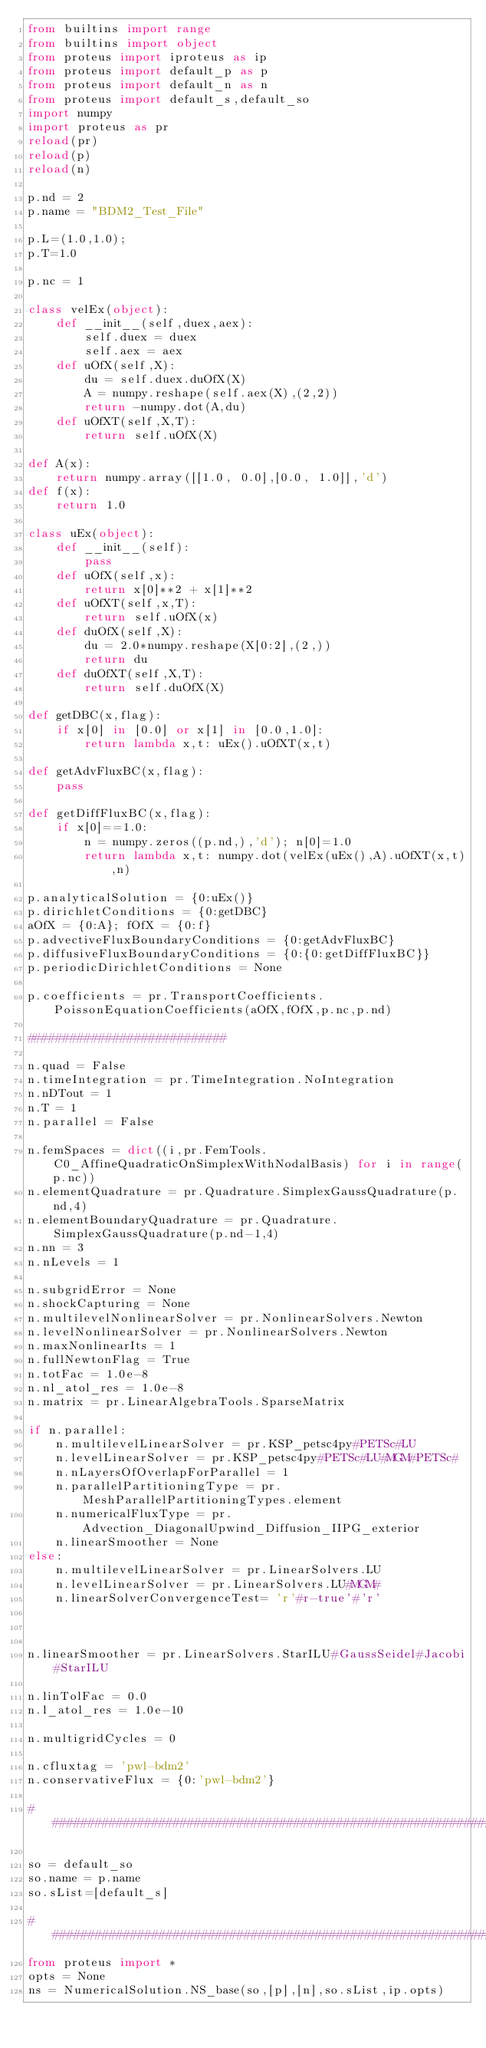<code> <loc_0><loc_0><loc_500><loc_500><_Python_>from builtins import range
from builtins import object
from proteus import iproteus as ip
from proteus import default_p as p
from proteus import default_n as n
from proteus import default_s,default_so
import numpy
import proteus as pr
reload(pr)
reload(p)
reload(n)

p.nd = 2
p.name = "BDM2_Test_File"

p.L=(1.0,1.0);
p.T=1.0

p.nc = 1

class velEx(object):
    def __init__(self,duex,aex):
        self.duex = duex
        self.aex = aex
    def uOfX(self,X):
        du = self.duex.duOfX(X)
        A = numpy.reshape(self.aex(X),(2,2))
        return -numpy.dot(A,du)
    def uOfXT(self,X,T):
        return self.uOfX(X)

def A(x):
    return numpy.array([[1.0, 0.0],[0.0, 1.0]],'d')
def f(x):
    return 1.0

class uEx(object):
    def __init__(self):
        pass
    def uOfX(self,x):
        return x[0]**2 + x[1]**2
    def uOfXT(self,x,T):
        return self.uOfX(x)
    def duOfX(self,X):
        du = 2.0*numpy.reshape(X[0:2],(2,))
        return du
    def duOfXT(self,X,T):
        return self.duOfX(X)

def getDBC(x,flag):
    if x[0] in [0.0] or x[1] in [0.0,1.0]:
        return lambda x,t: uEx().uOfXT(x,t)

def getAdvFluxBC(x,flag):
    pass

def getDiffFluxBC(x,flag):
    if x[0]==1.0:
        n = numpy.zeros((p.nd,),'d'); n[0]=1.0
        return lambda x,t: numpy.dot(velEx(uEx(),A).uOfXT(x,t),n)

p.analyticalSolution = {0:uEx()}
p.dirichletConditions = {0:getDBC}
aOfX = {0:A}; fOfX = {0:f}
p.advectiveFluxBoundaryConditions = {0:getAdvFluxBC}
p.diffusiveFluxBoundaryConditions = {0:{0:getDiffFluxBC}}
p.periodicDirichletConditions = None

p.coefficients = pr.TransportCoefficients.PoissonEquationCoefficients(aOfX,fOfX,p.nc,p.nd)

############################

n.quad = False
n.timeIntegration = pr.TimeIntegration.NoIntegration
n.nDTout = 1
n.T = 1
n.parallel = False

n.femSpaces = dict((i,pr.FemTools.C0_AffineQuadraticOnSimplexWithNodalBasis) for i in range(p.nc))
n.elementQuadrature = pr.Quadrature.SimplexGaussQuadrature(p.nd,4)
n.elementBoundaryQuadrature = pr.Quadrature.SimplexGaussQuadrature(p.nd-1,4)
n.nn = 3
n.nLevels = 1

n.subgridError = None
n.shockCapturing = None
n.multilevelNonlinearSolver = pr.NonlinearSolvers.Newton
n.levelNonlinearSolver = pr.NonlinearSolvers.Newton
n.maxNonlinearIts = 1
n.fullNewtonFlag = True
n.totFac = 1.0e-8
n.nl_atol_res = 1.0e-8
n.matrix = pr.LinearAlgebraTools.SparseMatrix

if n.parallel:
    n.multilevelLinearSolver = pr.KSP_petsc4py#PETSc#LU
    n.levelLinearSolver = pr.KSP_petsc4py#PETSc#LU#MGM#PETSc#
    n.nLayersOfOverlapForParallel = 1
    n.parallelPartitioningType = pr.MeshParallelPartitioningTypes.element
    n.numericalFluxType = pr.Advection_DiagonalUpwind_Diffusion_IIPG_exterior
    n.linearSmoother = None
else:
    n.multilevelLinearSolver = pr.LinearSolvers.LU
    n.levelLinearSolver = pr.LinearSolvers.LU#MGM#
    n.linearSolverConvergenceTest= 'r'#r-true'#'r'



n.linearSmoother = pr.LinearSolvers.StarILU#GaussSeidel#Jacobi#StarILU

n.linTolFac = 0.0
n.l_atol_res = 1.0e-10

n.multigridCycles = 0

n.cfluxtag = 'pwl-bdm2'
n.conservativeFlux = {0:'pwl-bdm2'}

#########################################################################

so = default_so
so.name = p.name 
so.sList=[default_s]

########################################################################
from proteus import *
opts = None
ns = NumericalSolution.NS_base(so,[p],[n],so.sList,ip.opts)
</code> 